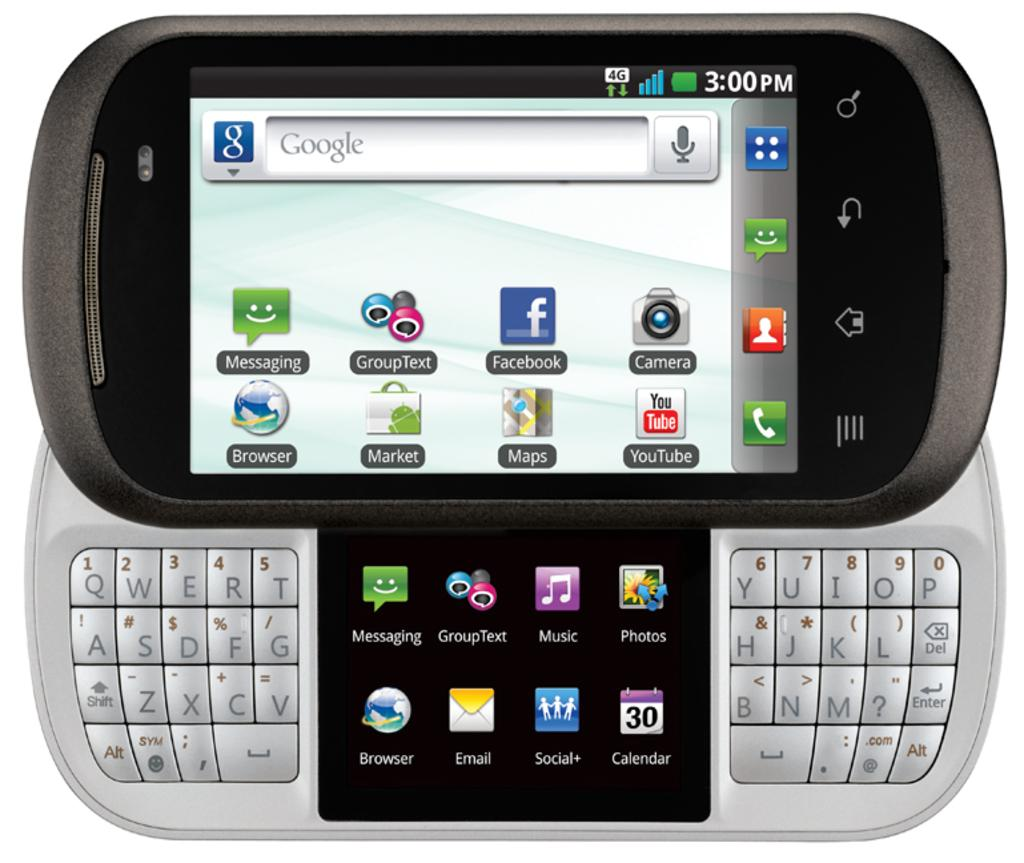<image>
Write a terse but informative summary of the picture. Google Smartphone that says 3:00 PM and has different apps. 